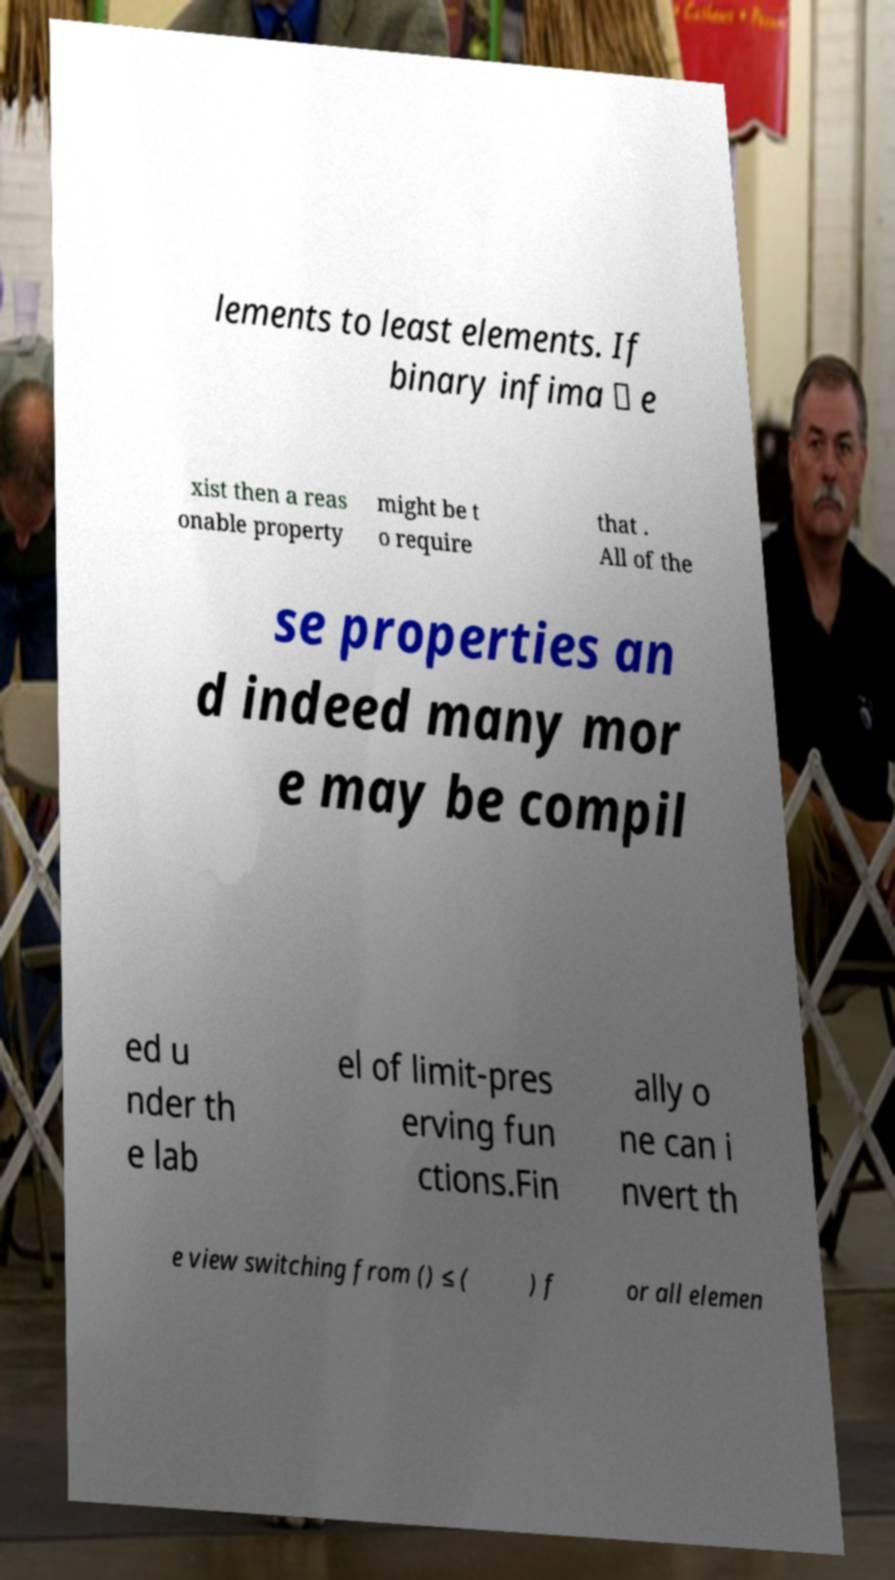Can you read and provide the text displayed in the image?This photo seems to have some interesting text. Can you extract and type it out for me? lements to least elements. If binary infima ∧ e xist then a reas onable property might be t o require that . All of the se properties an d indeed many mor e may be compil ed u nder th e lab el of limit-pres erving fun ctions.Fin ally o ne can i nvert th e view switching from () ≤ ( ) f or all elemen 